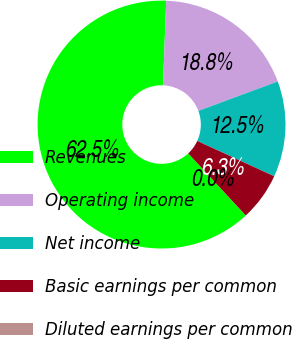Convert chart. <chart><loc_0><loc_0><loc_500><loc_500><pie_chart><fcel>Revenues<fcel>Operating income<fcel>Net income<fcel>Basic earnings per common<fcel>Diluted earnings per common<nl><fcel>62.48%<fcel>18.75%<fcel>12.5%<fcel>6.26%<fcel>0.01%<nl></chart> 